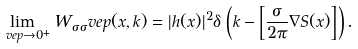Convert formula to latex. <formula><loc_0><loc_0><loc_500><loc_500>\lim _ { \ v e p \to 0 ^ { + } } W _ { \sigma \sigma } ^ { \ } v e p ( x , k ) = | h ( x ) | ^ { 2 } \delta \, \left ( k - \left [ \frac { \sigma } { 2 \pi } \nabla S ( x ) \right ] \right ) .</formula> 